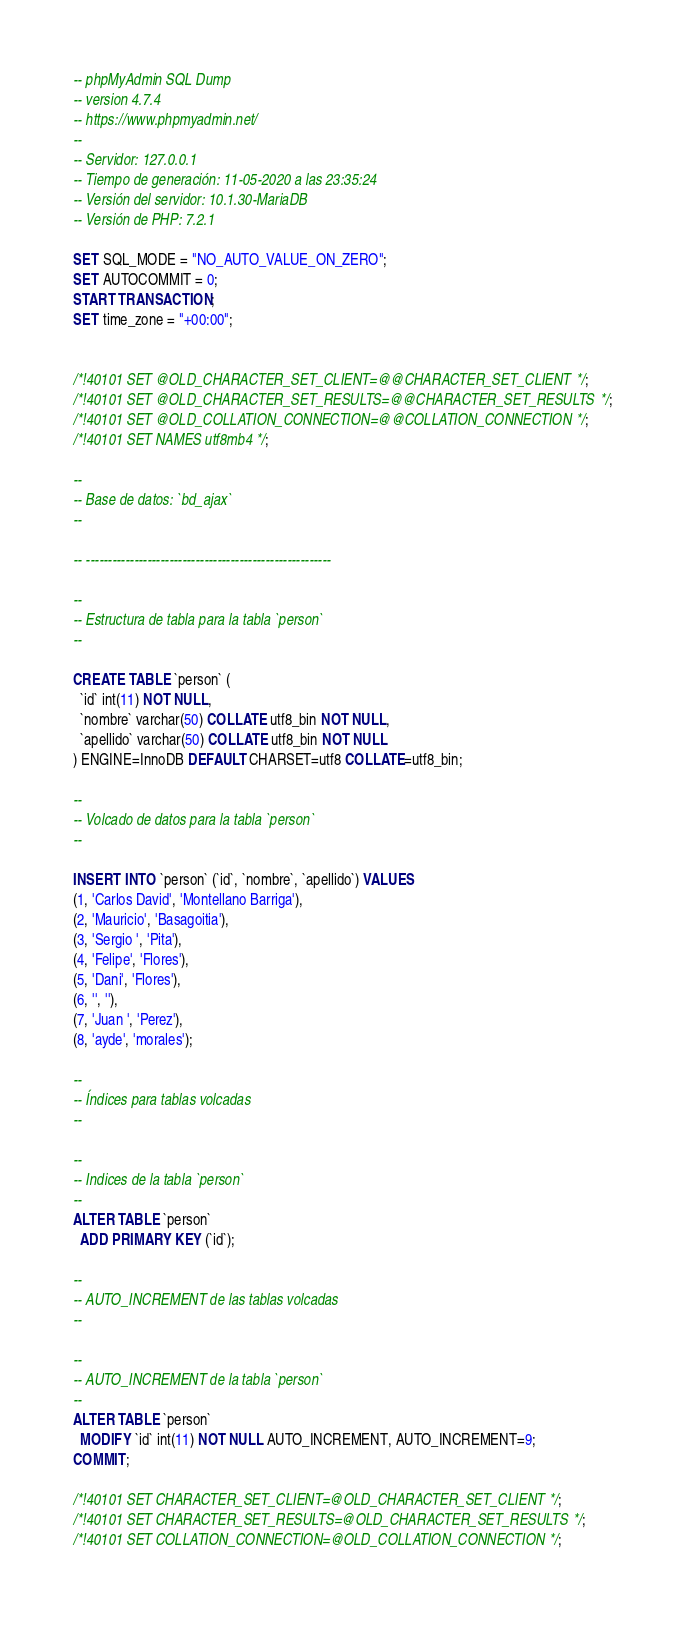Convert code to text. <code><loc_0><loc_0><loc_500><loc_500><_SQL_>-- phpMyAdmin SQL Dump
-- version 4.7.4
-- https://www.phpmyadmin.net/
--
-- Servidor: 127.0.0.1
-- Tiempo de generación: 11-05-2020 a las 23:35:24
-- Versión del servidor: 10.1.30-MariaDB
-- Versión de PHP: 7.2.1

SET SQL_MODE = "NO_AUTO_VALUE_ON_ZERO";
SET AUTOCOMMIT = 0;
START TRANSACTION;
SET time_zone = "+00:00";


/*!40101 SET @OLD_CHARACTER_SET_CLIENT=@@CHARACTER_SET_CLIENT */;
/*!40101 SET @OLD_CHARACTER_SET_RESULTS=@@CHARACTER_SET_RESULTS */;
/*!40101 SET @OLD_COLLATION_CONNECTION=@@COLLATION_CONNECTION */;
/*!40101 SET NAMES utf8mb4 */;

--
-- Base de datos: `bd_ajax`
--

-- --------------------------------------------------------

--
-- Estructura de tabla para la tabla `person`
--

CREATE TABLE `person` (
  `id` int(11) NOT NULL,
  `nombre` varchar(50) COLLATE utf8_bin NOT NULL,
  `apellido` varchar(50) COLLATE utf8_bin NOT NULL
) ENGINE=InnoDB DEFAULT CHARSET=utf8 COLLATE=utf8_bin;

--
-- Volcado de datos para la tabla `person`
--

INSERT INTO `person` (`id`, `nombre`, `apellido`) VALUES
(1, 'Carlos David', 'Montellano Barriga'),
(2, 'Mauricio', 'Basagoitia'),
(3, 'Sergio ', 'Pita'),
(4, 'Felipe', 'Flores'),
(5, 'Dani', 'Flores'),
(6, '', ''),
(7, 'Juan ', 'Perez'),
(8, 'ayde', 'morales');

--
-- Índices para tablas volcadas
--

--
-- Indices de la tabla `person`
--
ALTER TABLE `person`
  ADD PRIMARY KEY (`id`);

--
-- AUTO_INCREMENT de las tablas volcadas
--

--
-- AUTO_INCREMENT de la tabla `person`
--
ALTER TABLE `person`
  MODIFY `id` int(11) NOT NULL AUTO_INCREMENT, AUTO_INCREMENT=9;
COMMIT;

/*!40101 SET CHARACTER_SET_CLIENT=@OLD_CHARACTER_SET_CLIENT */;
/*!40101 SET CHARACTER_SET_RESULTS=@OLD_CHARACTER_SET_RESULTS */;
/*!40101 SET COLLATION_CONNECTION=@OLD_COLLATION_CONNECTION */;
</code> 